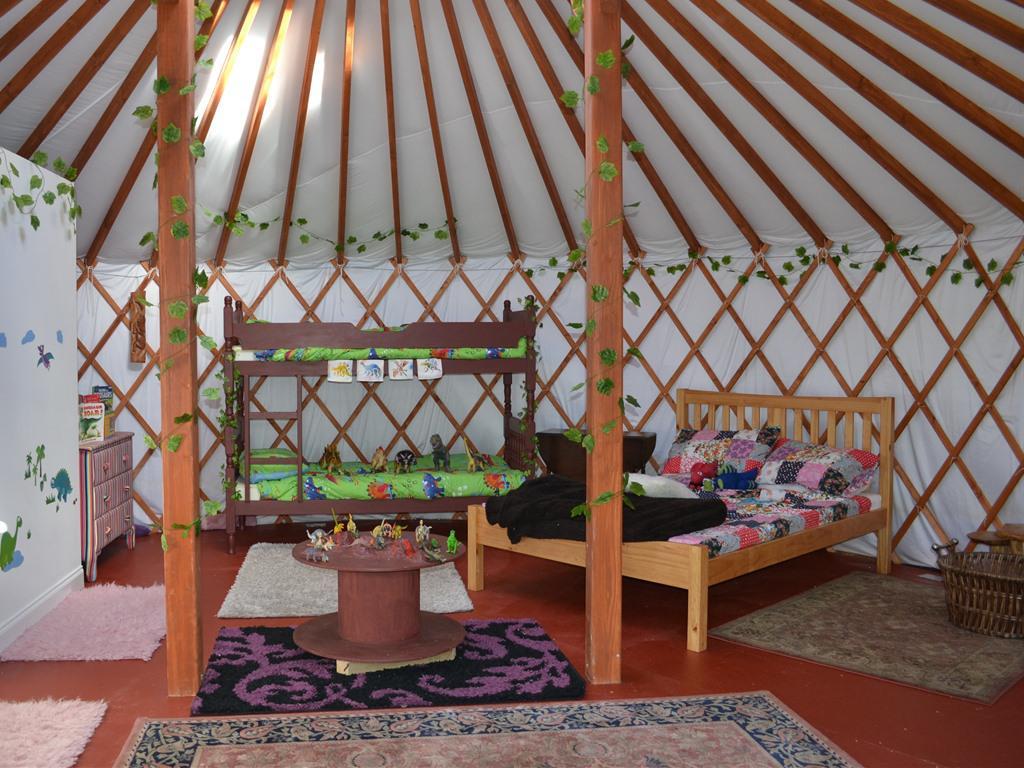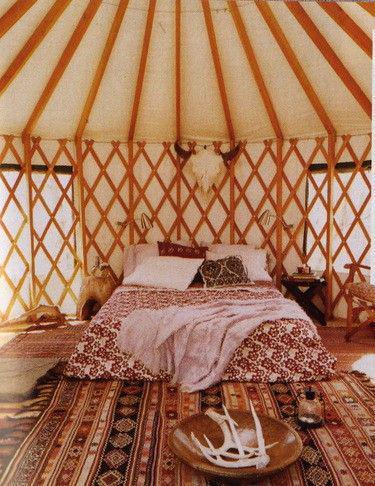The first image is the image on the left, the second image is the image on the right. Examine the images to the left and right. Is the description "In one image, a stainless steel refrigerator is in the kitchen area of a yurt, while a second image shows a bedroom area." accurate? Answer yes or no. No. The first image is the image on the left, the second image is the image on the right. Considering the images on both sides, is "The refridgerator is set up near the wall of a tent." valid? Answer yes or no. No. 